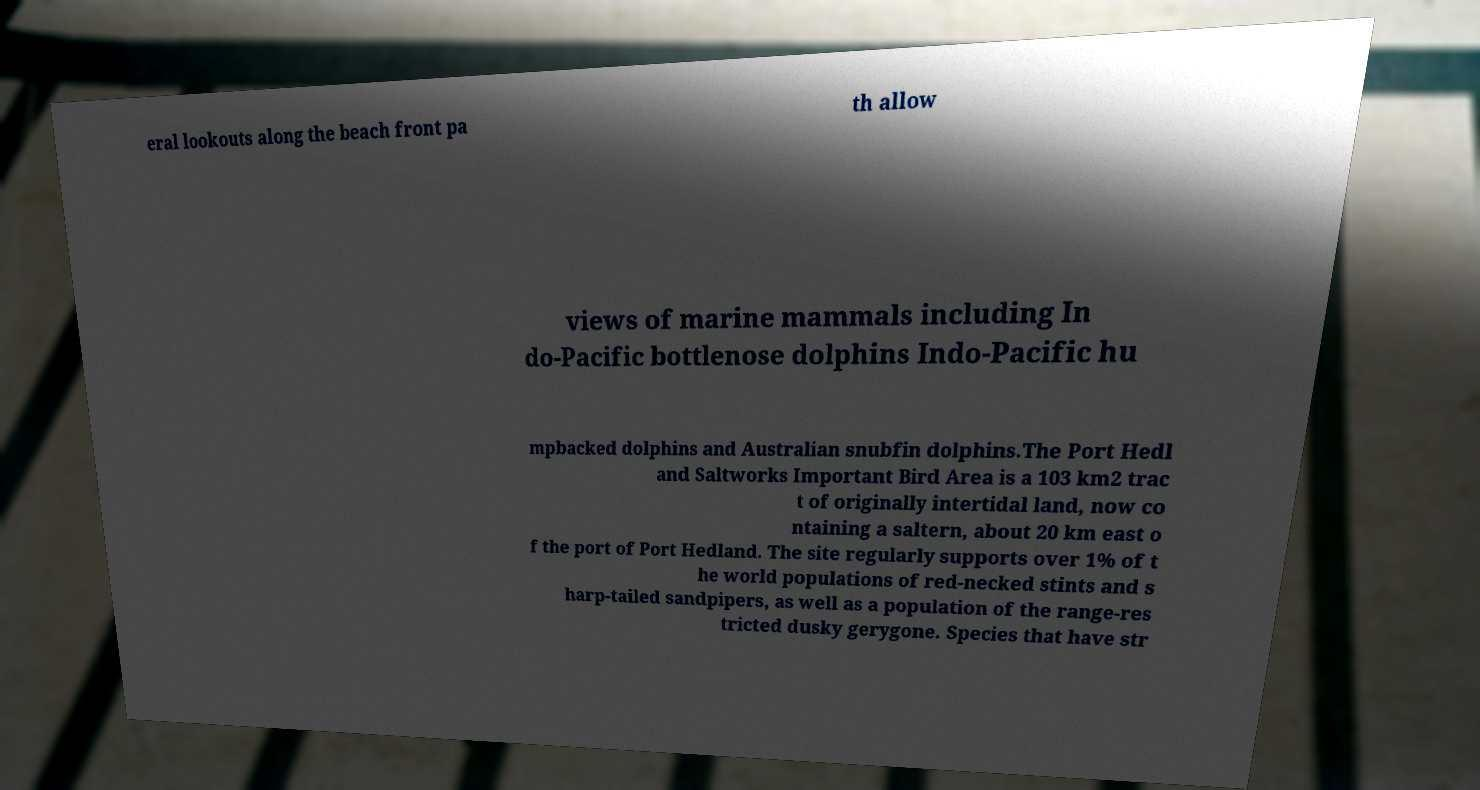Can you read and provide the text displayed in the image?This photo seems to have some interesting text. Can you extract and type it out for me? eral lookouts along the beach front pa th allow views of marine mammals including In do-Pacific bottlenose dolphins Indo-Pacific hu mpbacked dolphins and Australian snubfin dolphins.The Port Hedl and Saltworks Important Bird Area is a 103 km2 trac t of originally intertidal land, now co ntaining a saltern, about 20 km east o f the port of Port Hedland. The site regularly supports over 1% of t he world populations of red-necked stints and s harp-tailed sandpipers, as well as a population of the range-res tricted dusky gerygone. Species that have str 